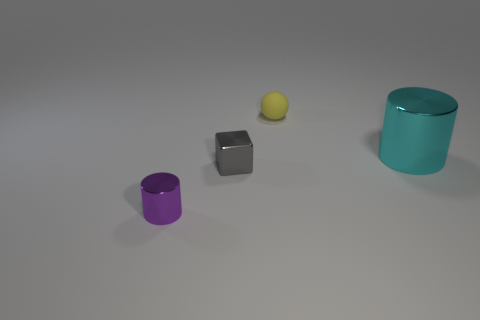Subtract all purple cylinders. How many cylinders are left? 1 Add 3 big purple shiny things. How many objects exist? 7 Subtract all balls. How many objects are left? 3 Add 2 tiny rubber spheres. How many tiny rubber spheres exist? 3 Subtract 0 yellow cubes. How many objects are left? 4 Subtract all gray cylinders. Subtract all gray balls. How many cylinders are left? 2 Subtract all gray shiny cubes. Subtract all tiny shiny objects. How many objects are left? 1 Add 1 yellow rubber objects. How many yellow rubber objects are left? 2 